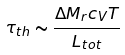<formula> <loc_0><loc_0><loc_500><loc_500>\tau _ { t h } \sim \frac { \Delta M _ { r } c _ { V } T } { L _ { t o t } }</formula> 